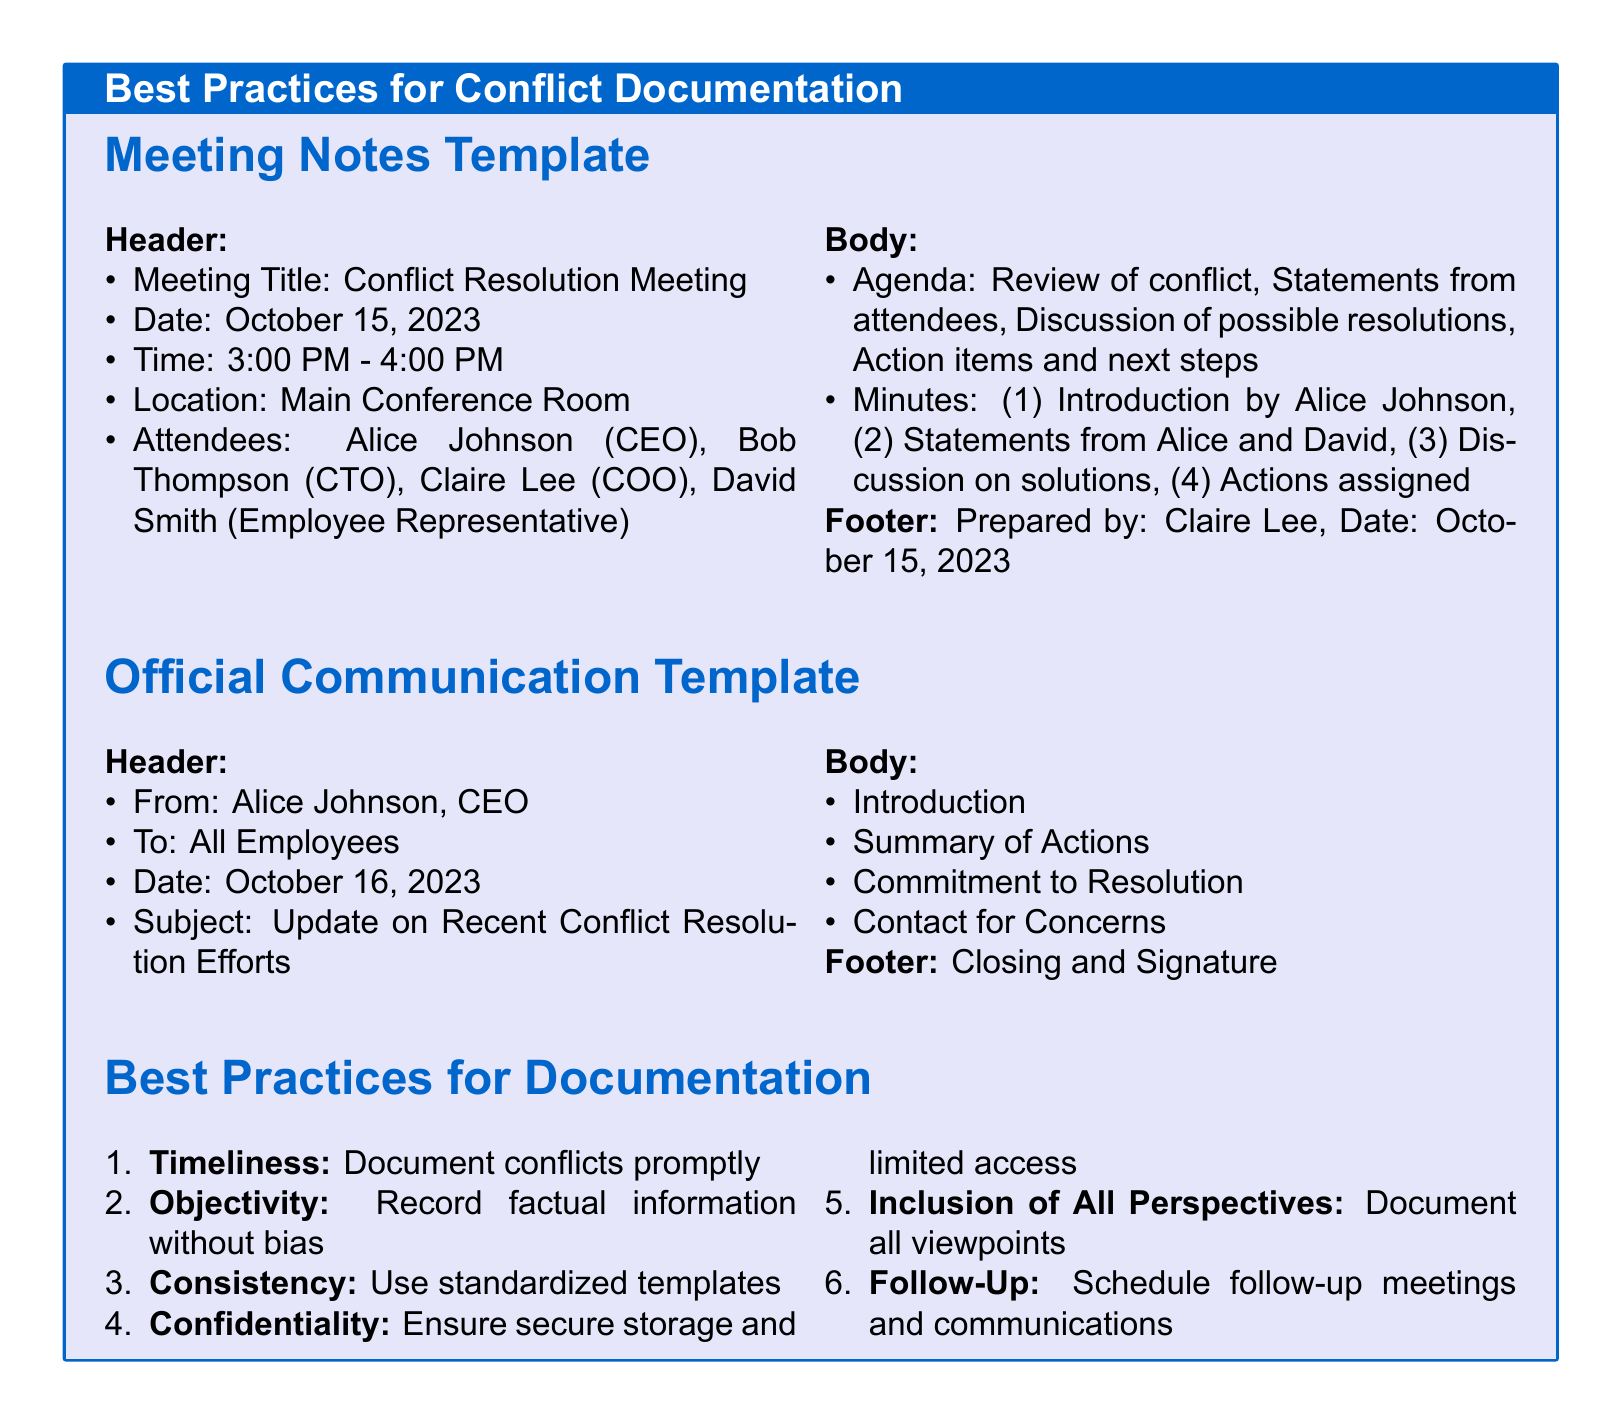what is the meeting title? The meeting title is mentioned in the header of the Meeting Notes Template.
Answer: Conflict Resolution Meeting who prepared the meeting notes? The footer of the Meeting Notes Template indicates who prepared the notes and the date.
Answer: Claire Lee what is the date of the official communication? The date can be found in the header of the Official Communication Template.
Answer: October 16, 2023 how many attendees were listed in the Meeting Notes Template? The number of attendees is counted from the list provided in the header of the Meeting Notes Template.
Answer: 4 what is the first best practice listed for documentation? The best practices for documentation are numbered, and the first one is in the enumerated list.
Answer: Timeliness what is the subject of the official communication? The subject is included in the header of the Official Communication Template.
Answer: Update on Recent Conflict Resolution Efforts what is listed as the second item in the Meeting Notes agenda? The agenda items are listed in the body of the Meeting Notes Template.
Answer: Statements from attendees who is the employee representative in the meeting? The name of the employee representative is mentioned in the attendees section of the Meeting Notes Template.
Answer: David Smith 